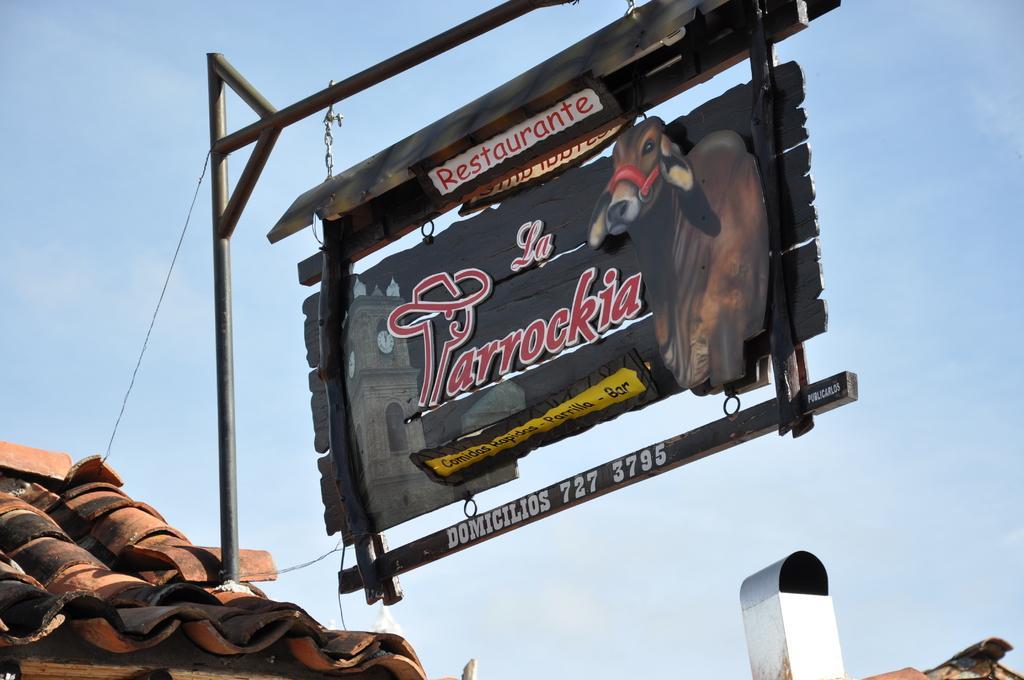Can you describe this image briefly? In this image we can see a board to a pole with the picture of a cow and some text on it which is on the roof. On the backside we can see the sky which looks cloudy. 